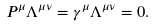<formula> <loc_0><loc_0><loc_500><loc_500>P ^ { \mu } \Lambda ^ { \mu \nu } = \gamma ^ { \mu } \Lambda ^ { \mu \nu } = 0 .</formula> 